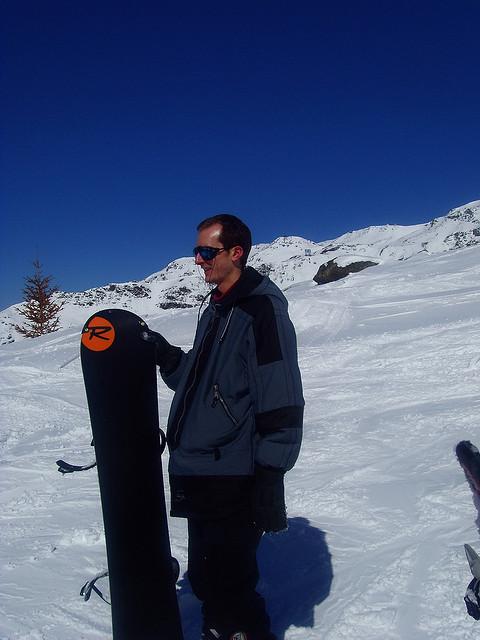Are there clouds in the sky?
Keep it brief. No. What is this man thinking?
Give a very brief answer. Its cold. Is this man waiting?
Short answer required. Yes. 